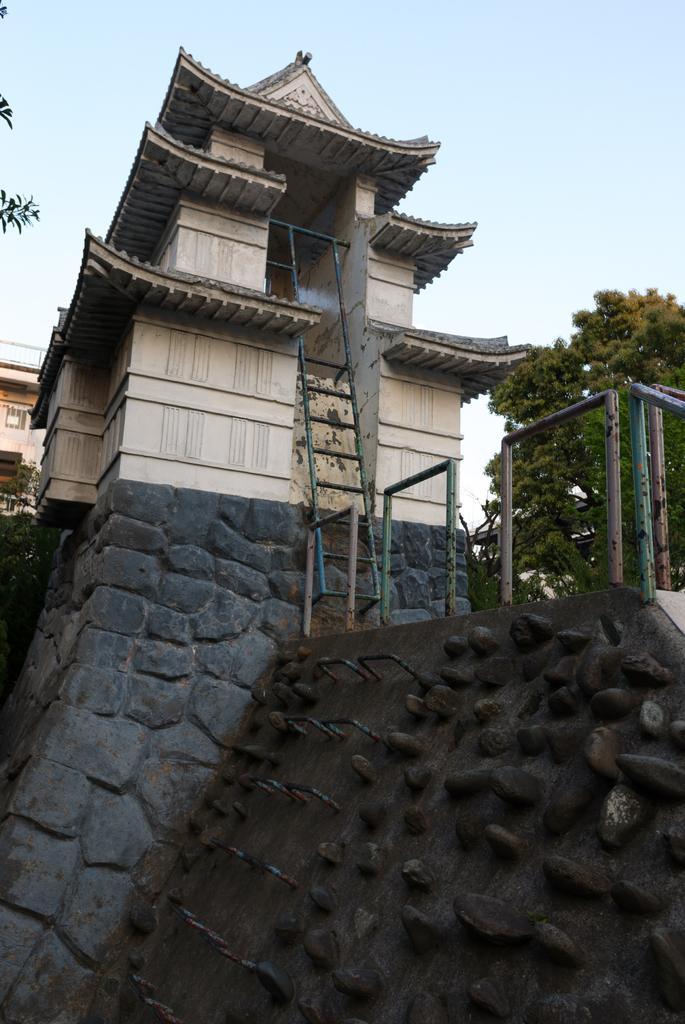Could you give a brief overview of what you see in this image? In this image I can see the wall which is made of rocks, few metal rods to the wall, the railing, few stairs which are made with metal rods and a building which is cream in color. In the background I can see another building, few trees and the sky. 